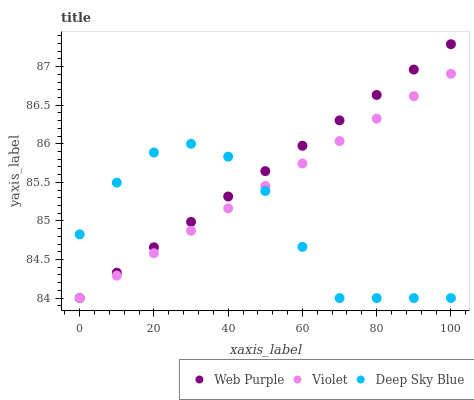Does Deep Sky Blue have the minimum area under the curve?
Answer yes or no. Yes. Does Web Purple have the maximum area under the curve?
Answer yes or no. Yes. Does Violet have the minimum area under the curve?
Answer yes or no. No. Does Violet have the maximum area under the curve?
Answer yes or no. No. Is Violet the smoothest?
Answer yes or no. Yes. Is Deep Sky Blue the roughest?
Answer yes or no. Yes. Is Deep Sky Blue the smoothest?
Answer yes or no. No. Is Violet the roughest?
Answer yes or no. No. Does Web Purple have the lowest value?
Answer yes or no. Yes. Does Web Purple have the highest value?
Answer yes or no. Yes. Does Violet have the highest value?
Answer yes or no. No. Does Deep Sky Blue intersect Violet?
Answer yes or no. Yes. Is Deep Sky Blue less than Violet?
Answer yes or no. No. Is Deep Sky Blue greater than Violet?
Answer yes or no. No. 